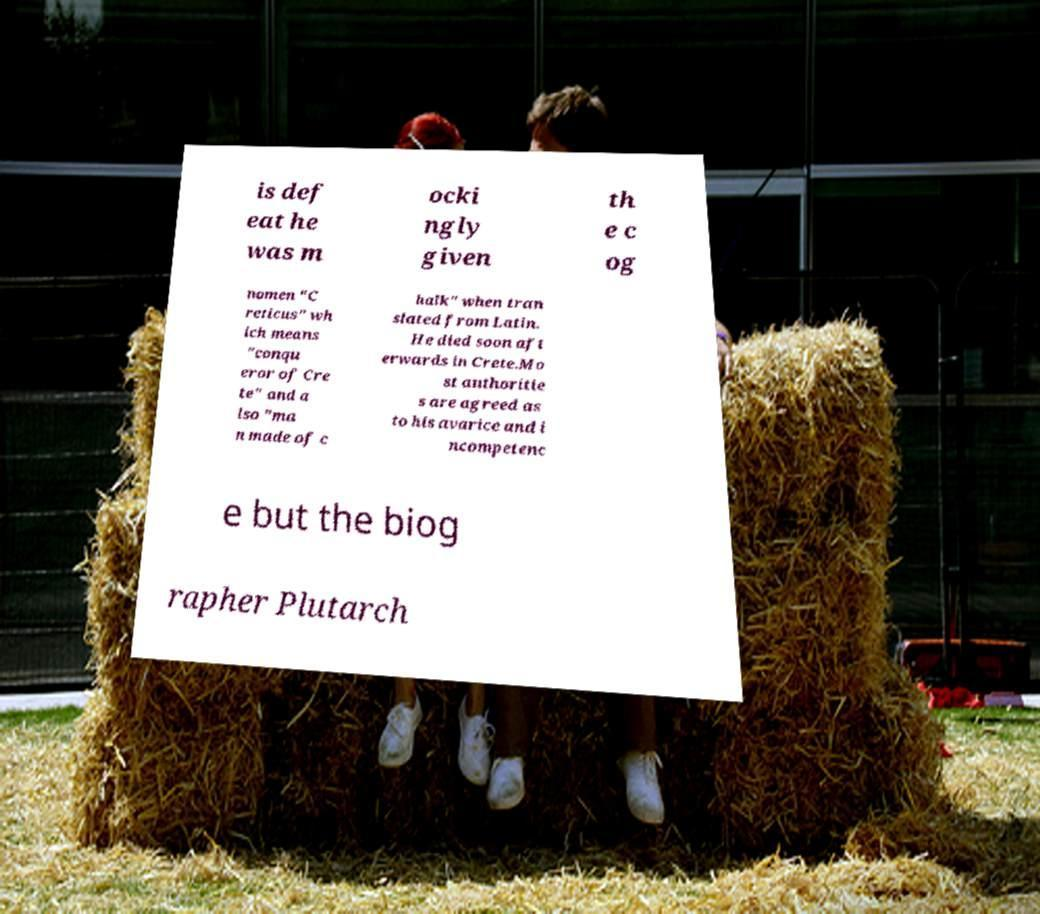I need the written content from this picture converted into text. Can you do that? is def eat he was m ocki ngly given th e c og nomen "C reticus" wh ich means "conqu eror of Cre te" and a lso "ma n made of c halk" when tran slated from Latin. He died soon aft erwards in Crete.Mo st authoritie s are agreed as to his avarice and i ncompetenc e but the biog rapher Plutarch 